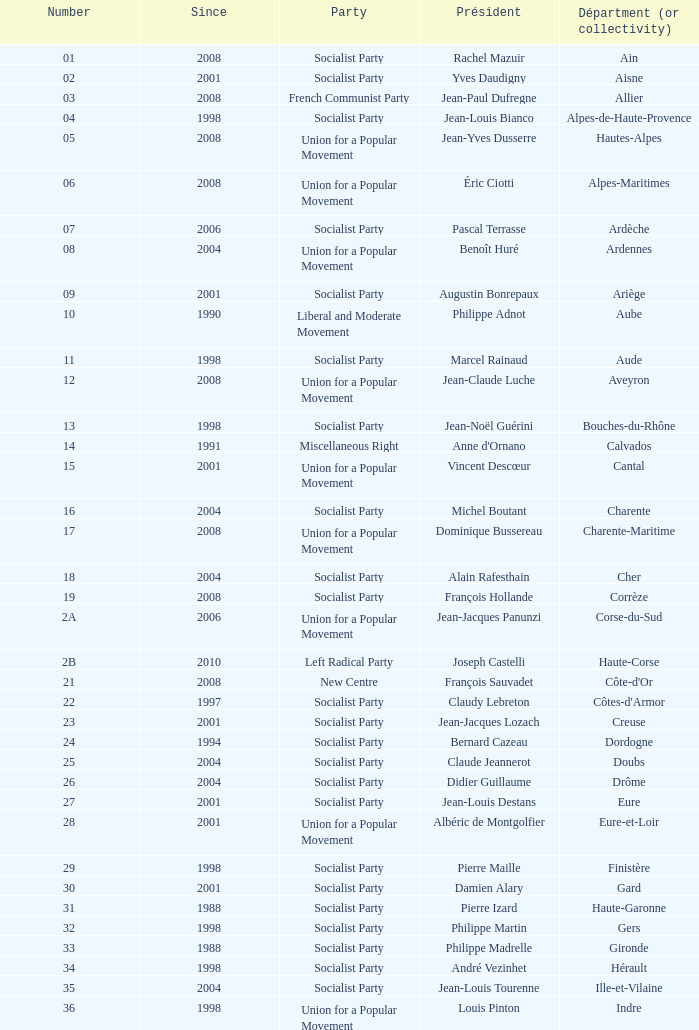Which department has Guy-Dominique Kennel as president since 2008? Bas-Rhin. 